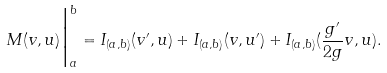<formula> <loc_0><loc_0><loc_500><loc_500>M ( v , u ) \Big | _ { a } ^ { b } = I _ { ( a , b ) } ( v ^ { \prime } , u ) + I _ { ( a , b ) } ( v , u ^ { \prime } ) + I _ { ( a , b ) } ( \frac { g ^ { \prime } } { 2 g } v , u ) .</formula> 